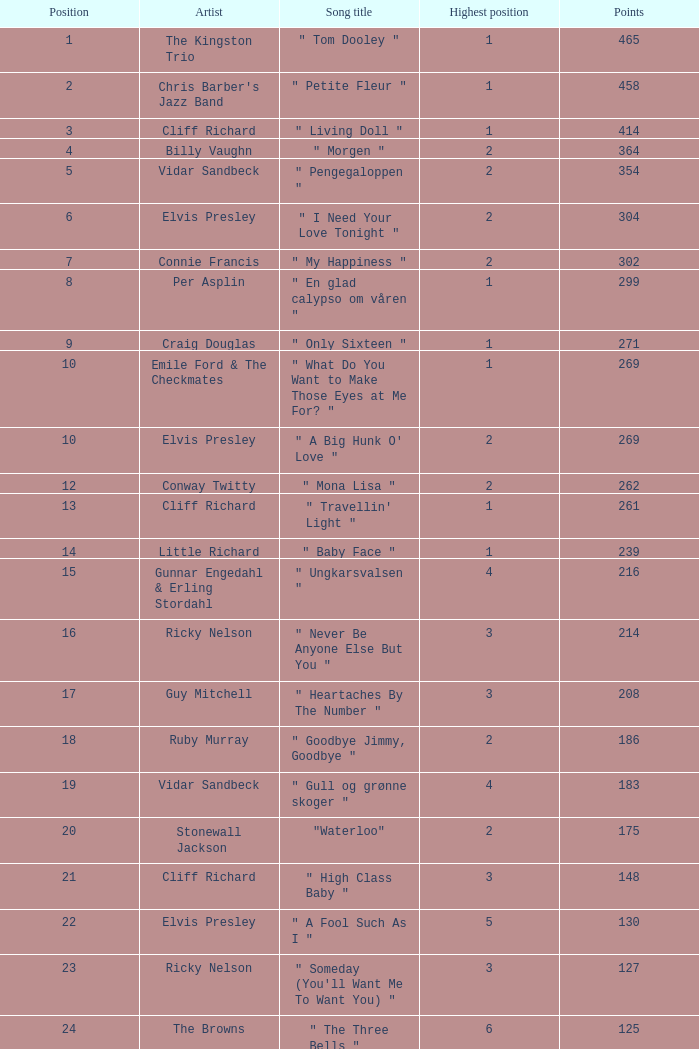What is the title of the song performed by billy vaughn? " Morgen ". 